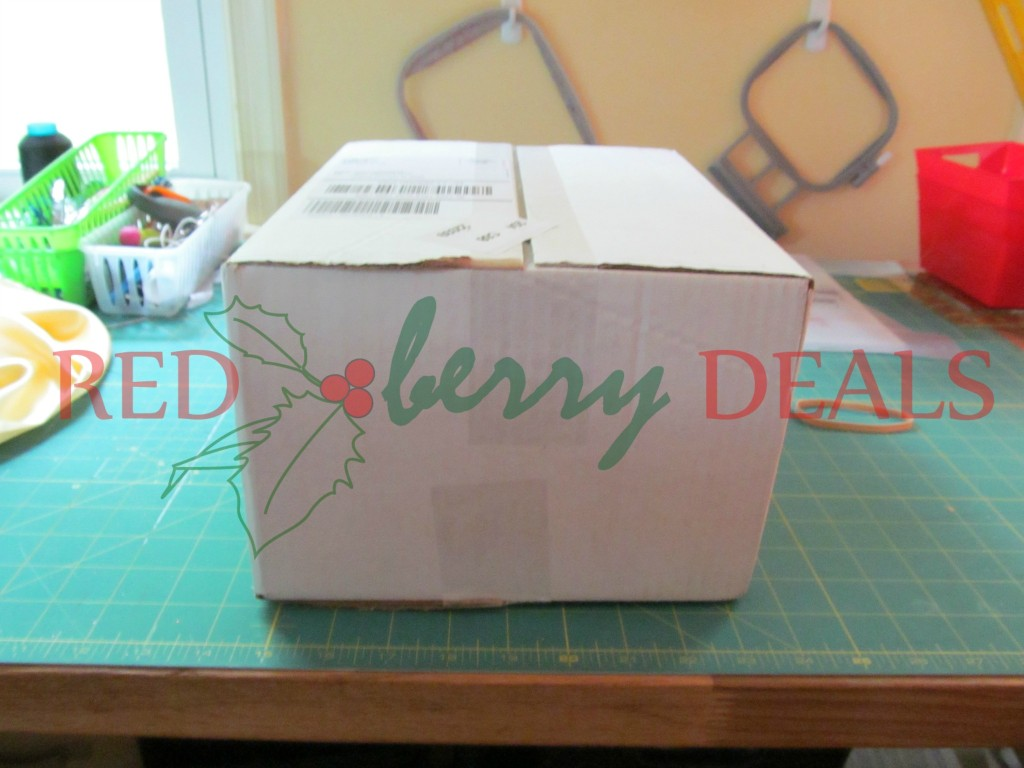What else can you observe on the table aside from the box? On the table, several objects are visible aside from the box. There are a couple of baskets to the left, one green and the other white, holding various items such as scissors, pens, and other small tools. There's even a yellow item that appears to be a palette or some sort of dish. Towards the back of the image, you can see the corner of a red bin and what looks like pieces of crafting or office supplies scattered around. 